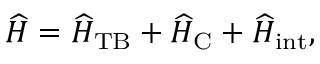<formula> <loc_0><loc_0><loc_500><loc_500>\widehat { H } = \widehat { H } _ { T B } + \widehat { H } _ { C } + \widehat { H } _ { i n t } ,</formula> 